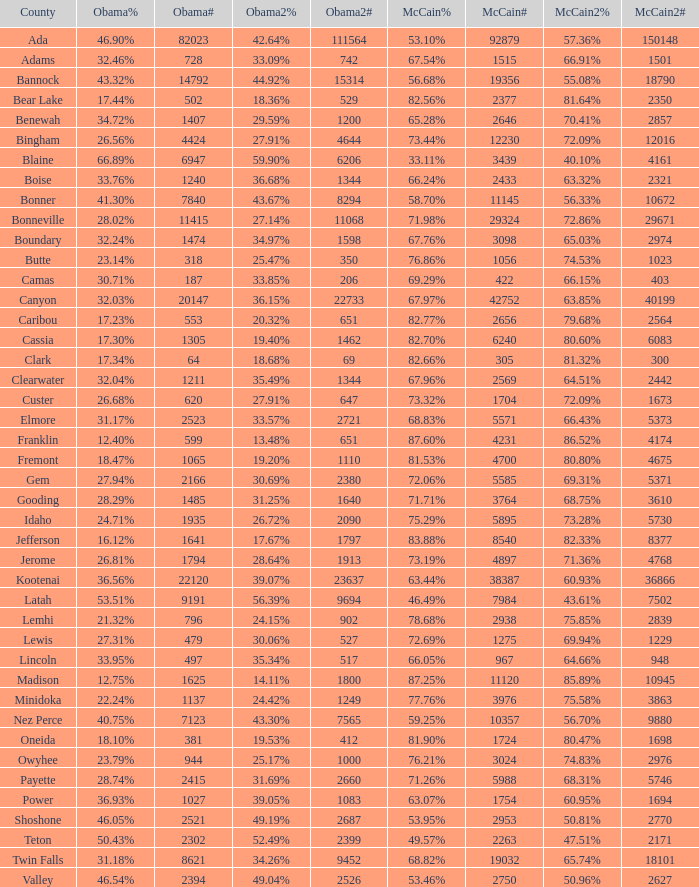For Gem County, what was the Obama vote percentage? 27.94%. 